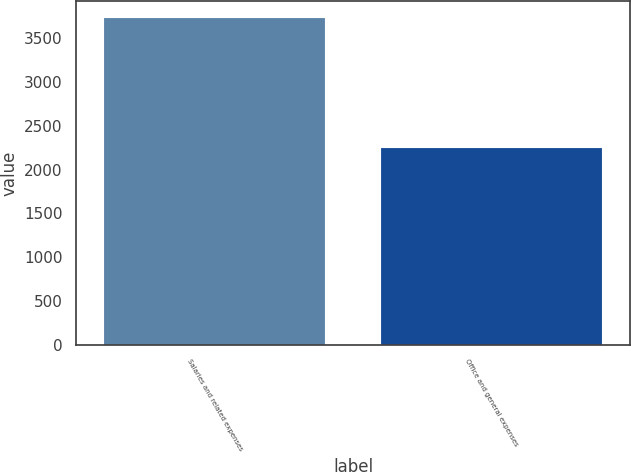Convert chart. <chart><loc_0><loc_0><loc_500><loc_500><bar_chart><fcel>Salaries and related expenses<fcel>Office and general expenses<nl><fcel>3733<fcel>2250.4<nl></chart> 